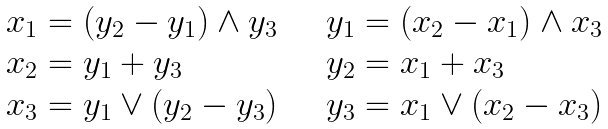<formula> <loc_0><loc_0><loc_500><loc_500>\begin{array} { l l } x _ { 1 } = ( y _ { 2 } - y _ { 1 } ) \wedge y _ { 3 } & \quad y _ { 1 } = ( x _ { 2 } - x _ { 1 } ) \wedge x _ { 3 } \\ x _ { 2 } = y _ { 1 } + y _ { 3 } & \quad y _ { 2 } = x _ { 1 } + x _ { 3 } \\ x _ { 3 } = y _ { 1 } \vee ( y _ { 2 } - y _ { 3 } ) & \quad y _ { 3 } = x _ { 1 } \vee ( x _ { 2 } - x _ { 3 } ) \\ \end{array}</formula> 